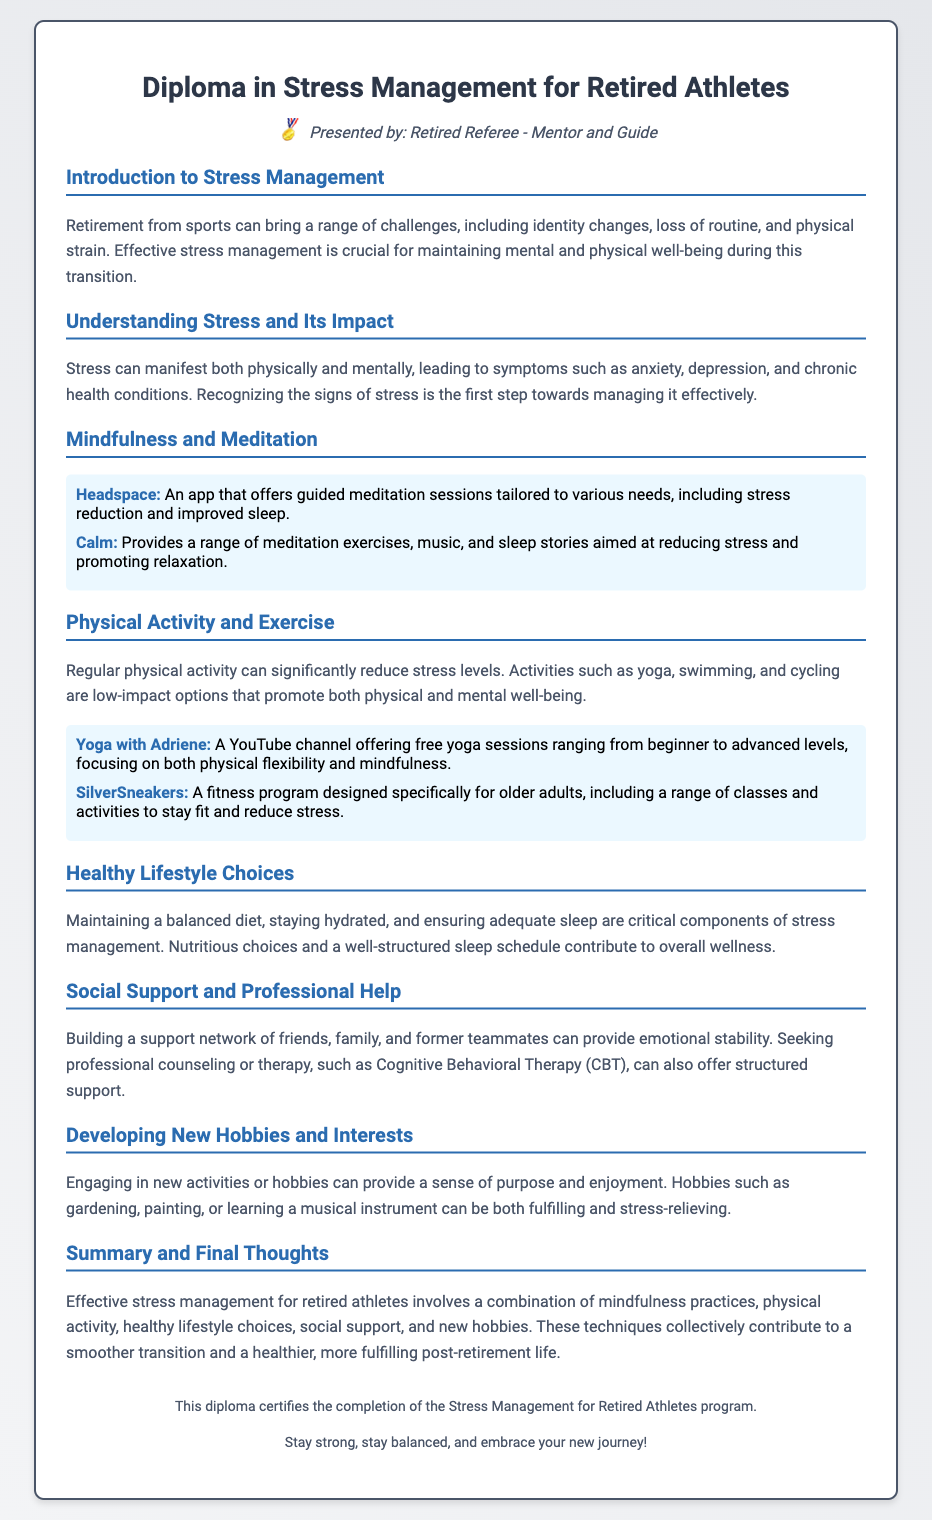what is the title of the diploma? The title of the diploma is stated at the top of the document.
Answer: Diploma in Stress Management for Retired Athletes who presented the diploma? The document mentions the presenter in the header section.
Answer: Retired Referee - Mentor and Guide what is one mental symptom of stress? The document lists mental symptoms in the section about understanding stress and its impact.
Answer: anxiety name one app for mindfulness and meditation mentioned in the document. The section on mindfulness and meditation provides examples of apps for this purpose.
Answer: Headspace what type of program is SilverSneakers? The document describes this program in the context of physical activity and exercise.
Answer: fitness program what is a suggested activity for engaging in new hobbies? The document provides examples of new activities that can alleviate stress.
Answer: gardening which therapy is mentioned as a professional help option? The document lists types of professional therapy in the social support section.
Answer: Cognitive Behavioral Therapy (CBT) what is recommended for maintaining a healthy lifestyle? The document emphasizes components of a healthy lifestyle in the respective section.
Answer: balanced diet how can retired athletes reduce stress through physical activity? The document highlights this in the physical activity section, summarizing its benefits.
Answer: Regular physical activity 